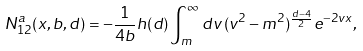<formula> <loc_0><loc_0><loc_500><loc_500>N _ { 1 2 } ^ { a } ( x , b , d ) = - \frac { 1 } { 4 b } h ( d ) \int _ { m } ^ { \infty } d v \, ( v ^ { 2 } - m ^ { 2 } ) ^ { \frac { d - 4 } { 2 } } e ^ { - 2 v x } ,</formula> 